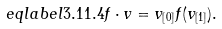Convert formula to latex. <formula><loc_0><loc_0><loc_500><loc_500>\ e q l a b e l { 3 . 1 1 . 4 } f \cdot v = v _ { [ 0 ] } f ( v _ { [ 1 ] } ) .</formula> 